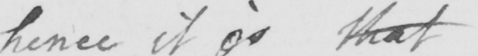Can you read and transcribe this handwriting? hence it is that 